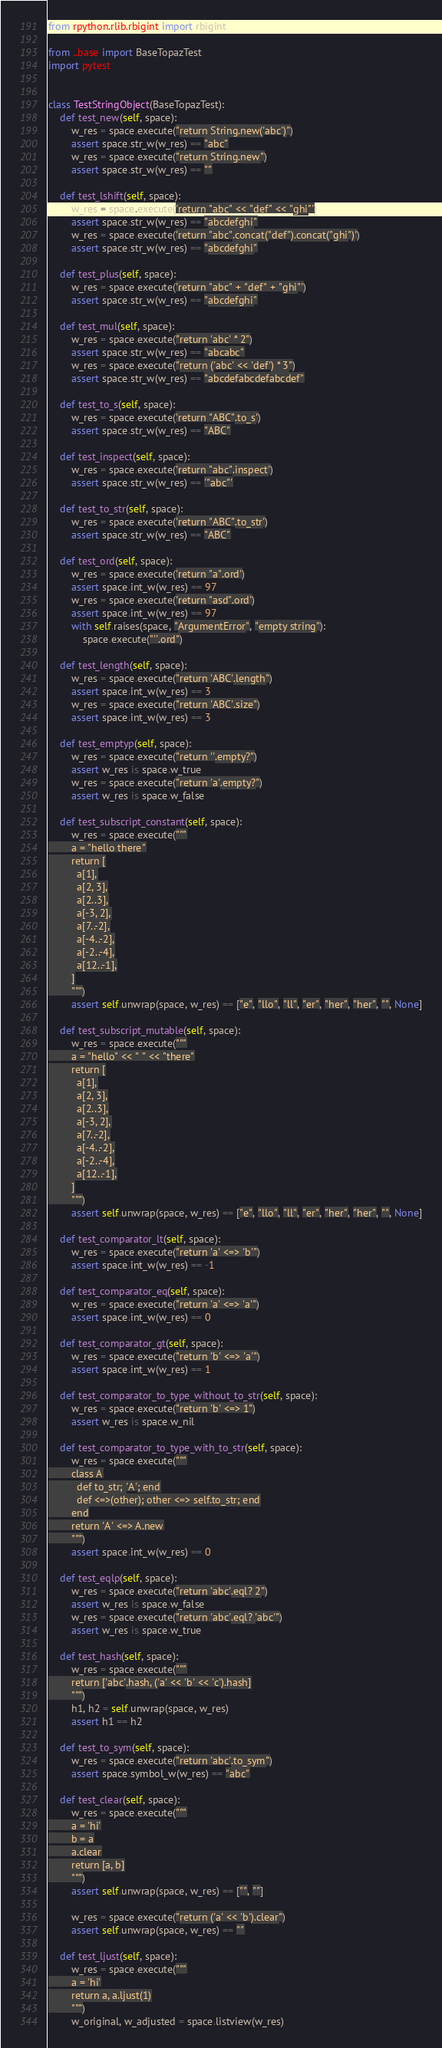Convert code to text. <code><loc_0><loc_0><loc_500><loc_500><_Python_>from rpython.rlib.rbigint import rbigint

from ..base import BaseTopazTest
import pytest


class TestStringObject(BaseTopazTest):
    def test_new(self, space):
        w_res = space.execute("return String.new('abc')")
        assert space.str_w(w_res) == "abc"
        w_res = space.execute("return String.new")
        assert space.str_w(w_res) == ""

    def test_lshift(self, space):
        w_res = space.execute('return "abc" << "def" << "ghi"')
        assert space.str_w(w_res) == "abcdefghi"
        w_res = space.execute('return "abc".concat("def").concat("ghi")')
        assert space.str_w(w_res) == "abcdefghi"

    def test_plus(self, space):
        w_res = space.execute('return "abc" + "def" + "ghi"')
        assert space.str_w(w_res) == "abcdefghi"

    def test_mul(self, space):
        w_res = space.execute("return 'abc' * 2")
        assert space.str_w(w_res) == "abcabc"
        w_res = space.execute("return ('abc' << 'def') * 3")
        assert space.str_w(w_res) == "abcdefabcdefabcdef"

    def test_to_s(self, space):
        w_res = space.execute('return "ABC".to_s')
        assert space.str_w(w_res) == "ABC"

    def test_inspect(self, space):
        w_res = space.execute('return "abc".inspect')
        assert space.str_w(w_res) == '"abc"'

    def test_to_str(self, space):
        w_res = space.execute('return "ABC".to_str')
        assert space.str_w(w_res) == "ABC"

    def test_ord(self, space):
        w_res = space.execute('return "a".ord')
        assert space.int_w(w_res) == 97
        w_res = space.execute('return "asd".ord')
        assert space.int_w(w_res) == 97
        with self.raises(space, "ArgumentError", "empty string"):
            space.execute("''.ord")

    def test_length(self, space):
        w_res = space.execute("return 'ABC'.length")
        assert space.int_w(w_res) == 3
        w_res = space.execute("return 'ABC'.size")
        assert space.int_w(w_res) == 3

    def test_emptyp(self, space):
        w_res = space.execute("return ''.empty?")
        assert w_res is space.w_true
        w_res = space.execute("return 'a'.empty?")
        assert w_res is space.w_false

    def test_subscript_constant(self, space):
        w_res = space.execute("""
        a = "hello there"
        return [
          a[1],
          a[2, 3],
          a[2..3],
          a[-3, 2],
          a[7..-2],
          a[-4..-2],
          a[-2..-4],
          a[12..-1],
        ]
        """)
        assert self.unwrap(space, w_res) == ["e", "llo", "ll", "er", "her", "her", "", None]

    def test_subscript_mutable(self, space):
        w_res = space.execute("""
        a = "hello" << " " << "there"
        return [
          a[1],
          a[2, 3],
          a[2..3],
          a[-3, 2],
          a[7..-2],
          a[-4..-2],
          a[-2..-4],
          a[12..-1],
        ]
        """)
        assert self.unwrap(space, w_res) == ["e", "llo", "ll", "er", "her", "her", "", None]

    def test_comparator_lt(self, space):
        w_res = space.execute("return 'a' <=> 'b'")
        assert space.int_w(w_res) == -1

    def test_comparator_eq(self, space):
        w_res = space.execute("return 'a' <=> 'a'")
        assert space.int_w(w_res) == 0

    def test_comparator_gt(self, space):
        w_res = space.execute("return 'b' <=> 'a'")
        assert space.int_w(w_res) == 1

    def test_comparator_to_type_without_to_str(self, space):
        w_res = space.execute("return 'b' <=> 1")
        assert w_res is space.w_nil

    def test_comparator_to_type_with_to_str(self, space):
        w_res = space.execute("""
        class A
          def to_str; 'A'; end
          def <=>(other); other <=> self.to_str; end
        end
        return 'A' <=> A.new
        """)
        assert space.int_w(w_res) == 0

    def test_eqlp(self, space):
        w_res = space.execute("return 'abc'.eql? 2")
        assert w_res is space.w_false
        w_res = space.execute("return 'abc'.eql? 'abc'")
        assert w_res is space.w_true

    def test_hash(self, space):
        w_res = space.execute("""
        return ['abc'.hash, ('a' << 'b' << 'c').hash]
        """)
        h1, h2 = self.unwrap(space, w_res)
        assert h1 == h2

    def test_to_sym(self, space):
        w_res = space.execute("return 'abc'.to_sym")
        assert space.symbol_w(w_res) == "abc"

    def test_clear(self, space):
        w_res = space.execute("""
        a = 'hi'
        b = a
        a.clear
        return [a, b]
        """)
        assert self.unwrap(space, w_res) == ["", ""]

        w_res = space.execute("return ('a' << 'b').clear")
        assert self.unwrap(space, w_res) == ""

    def test_ljust(self, space):
        w_res = space.execute("""
        a = 'hi'
        return a, a.ljust(1)
        """)
        w_original, w_adjusted = space.listview(w_res)</code> 